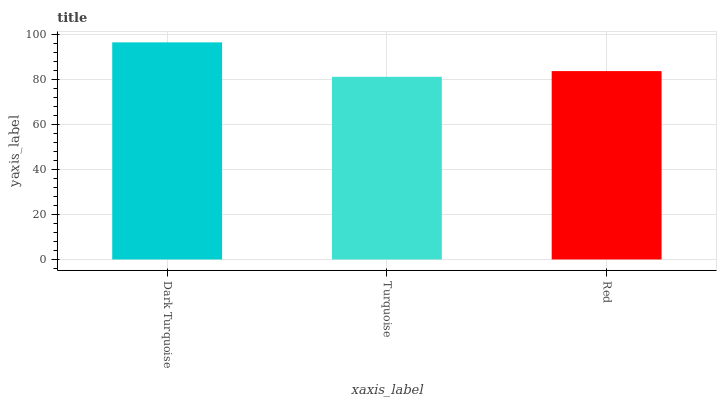Is Red the minimum?
Answer yes or no. No. Is Red the maximum?
Answer yes or no. No. Is Red greater than Turquoise?
Answer yes or no. Yes. Is Turquoise less than Red?
Answer yes or no. Yes. Is Turquoise greater than Red?
Answer yes or no. No. Is Red less than Turquoise?
Answer yes or no. No. Is Red the high median?
Answer yes or no. Yes. Is Red the low median?
Answer yes or no. Yes. Is Dark Turquoise the high median?
Answer yes or no. No. Is Dark Turquoise the low median?
Answer yes or no. No. 